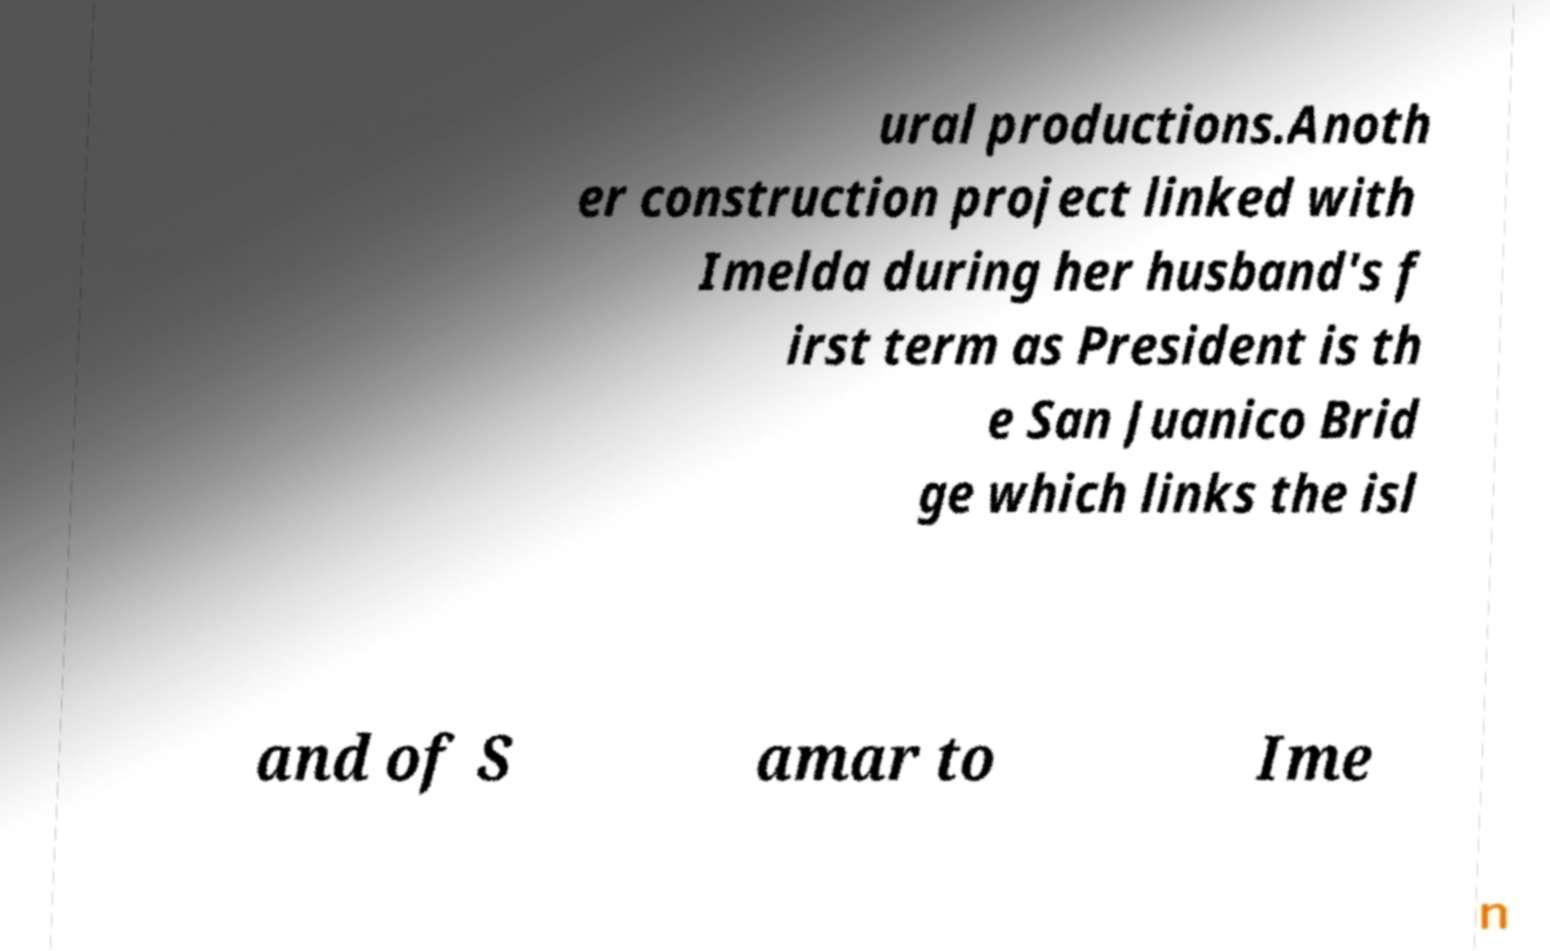I need the written content from this picture converted into text. Can you do that? ural productions.Anoth er construction project linked with Imelda during her husband's f irst term as President is th e San Juanico Brid ge which links the isl and of S amar to Ime 